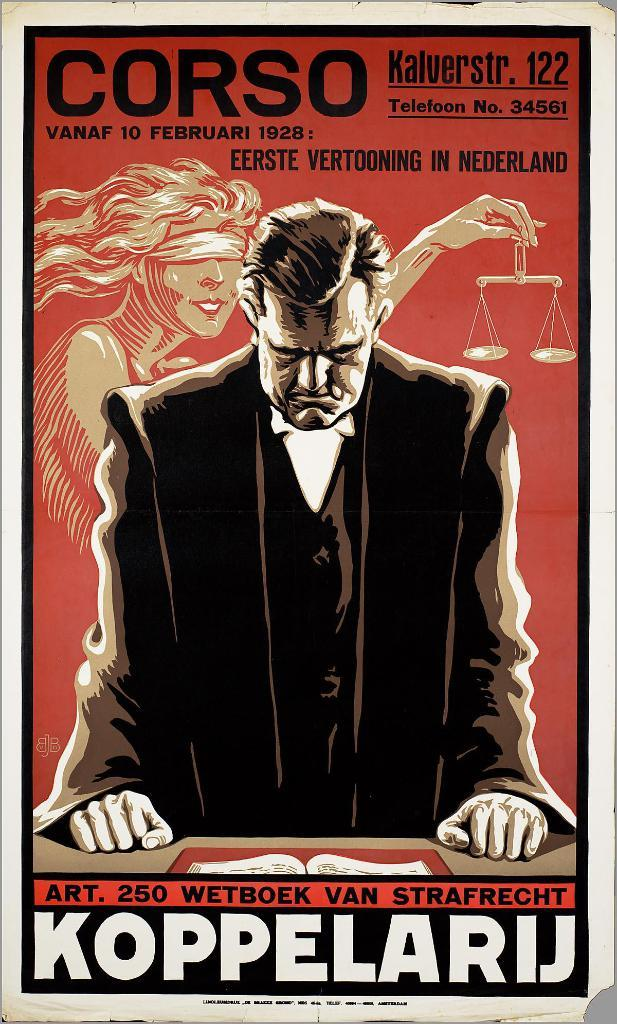Provide a one-sentence caption for the provided image. a poster with CORSO and KOPPELARIJ  on it. 